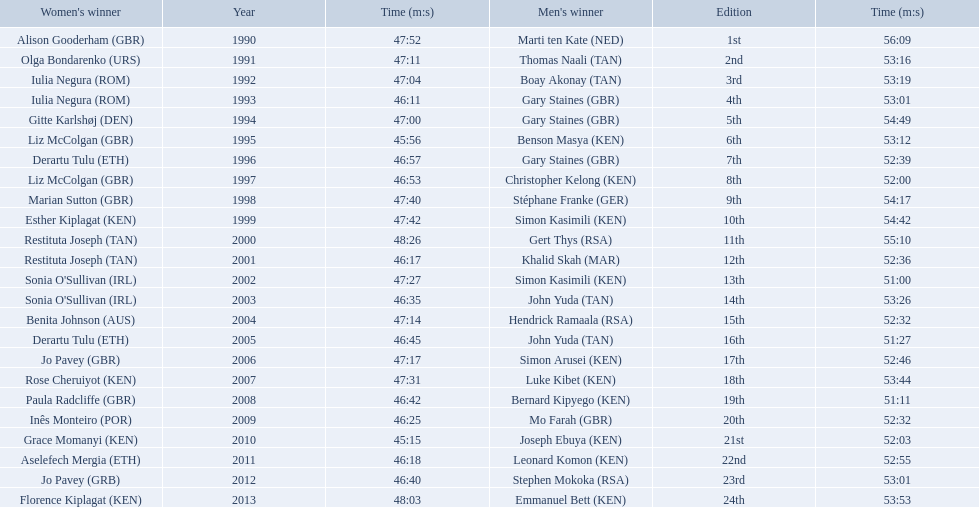Who were all the runners' times between 1990 and 2013? 47:52, 56:09, 47:11, 53:16, 47:04, 53:19, 46:11, 53:01, 47:00, 54:49, 45:56, 53:12, 46:57, 52:39, 46:53, 52:00, 47:40, 54:17, 47:42, 54:42, 48:26, 55:10, 46:17, 52:36, 47:27, 51:00, 46:35, 53:26, 47:14, 52:32, 46:45, 51:27, 47:17, 52:46, 47:31, 53:44, 46:42, 51:11, 46:25, 52:32, 45:15, 52:03, 46:18, 52:55, 46:40, 53:01, 48:03, 53:53. Which was the fastest time? 45:15. Who ran that time? Joseph Ebuya (KEN). 